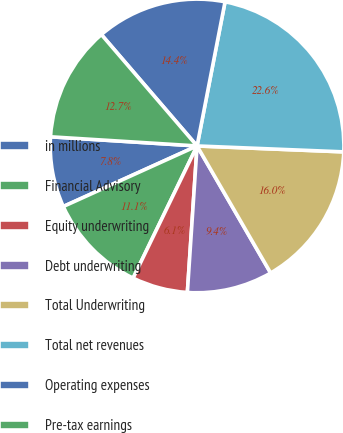Convert chart. <chart><loc_0><loc_0><loc_500><loc_500><pie_chart><fcel>in millions<fcel>Financial Advisory<fcel>Equity underwriting<fcel>Debt underwriting<fcel>Total Underwriting<fcel>Total net revenues<fcel>Operating expenses<fcel>Pre-tax earnings<nl><fcel>7.76%<fcel>11.06%<fcel>6.12%<fcel>9.41%<fcel>16.0%<fcel>22.59%<fcel>14.35%<fcel>12.71%<nl></chart> 